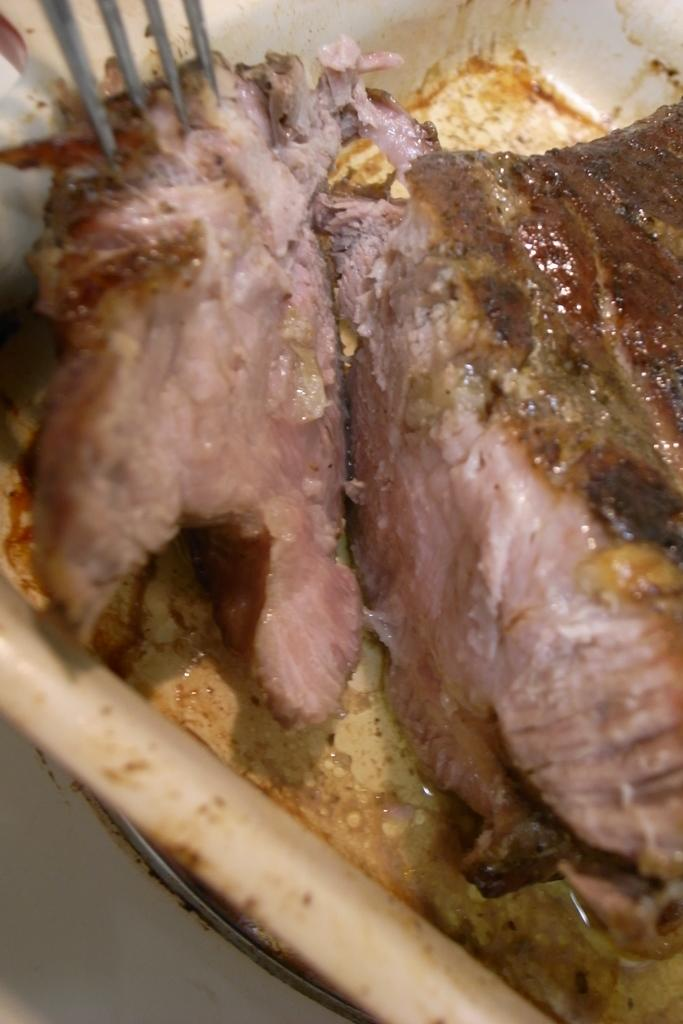What type of food is featured in the image? There is a meat dish in the image. How is the meat dish presented? The meat dish is placed on a plate. What utensil is used with the meat dish? There is a fork on the meat dish. What type of rabbit can be seen performing magic tricks with the meat dish in the image? There is no rabbit or magic tricks present in the image; it features a meat dish with a fork on a plate. 